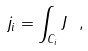Convert formula to latex. <formula><loc_0><loc_0><loc_500><loc_500>j _ { i } = \int _ { C _ { i } } J \ ,</formula> 